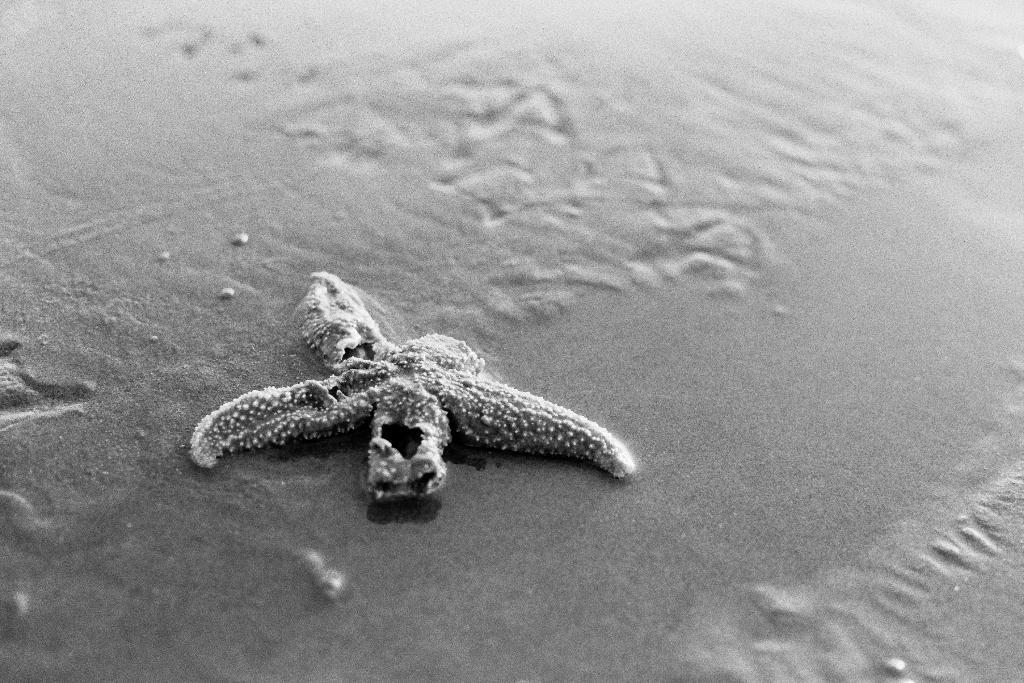In one or two sentences, can you explain what this image depicts? As we can see in the image there is water, sand and aquatic animal. 